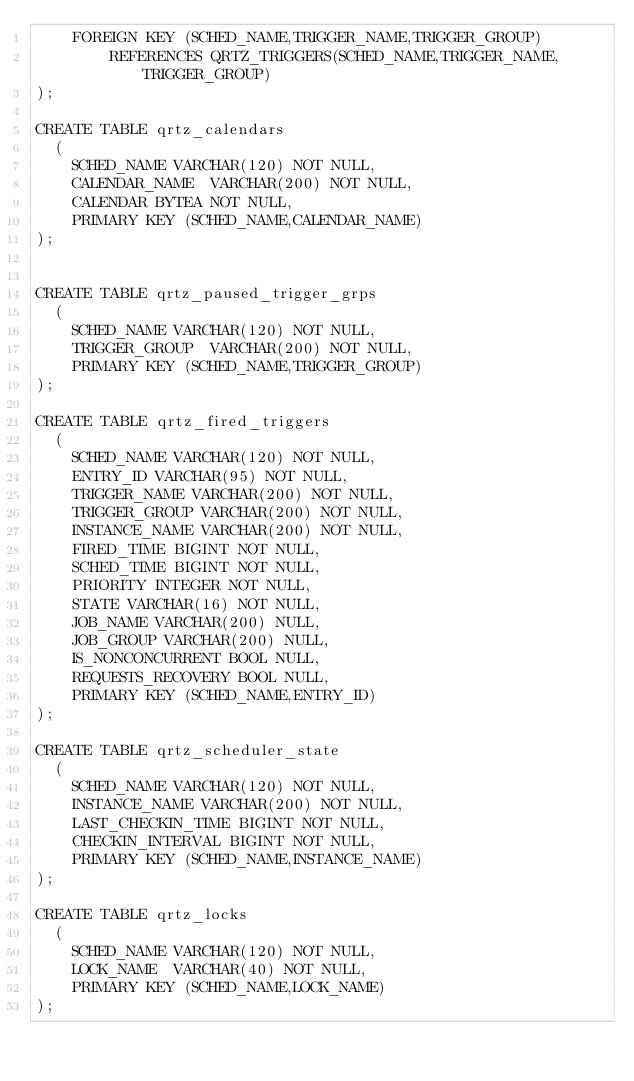Convert code to text. <code><loc_0><loc_0><loc_500><loc_500><_SQL_>    FOREIGN KEY (SCHED_NAME,TRIGGER_NAME,TRIGGER_GROUP) 
        REFERENCES QRTZ_TRIGGERS(SCHED_NAME,TRIGGER_NAME,TRIGGER_GROUP)
);

CREATE TABLE qrtz_calendars
  (
    SCHED_NAME VARCHAR(120) NOT NULL,
    CALENDAR_NAME  VARCHAR(200) NOT NULL, 
    CALENDAR BYTEA NOT NULL,
    PRIMARY KEY (SCHED_NAME,CALENDAR_NAME)
);


CREATE TABLE qrtz_paused_trigger_grps
  (
    SCHED_NAME VARCHAR(120) NOT NULL,
    TRIGGER_GROUP  VARCHAR(200) NOT NULL, 
    PRIMARY KEY (SCHED_NAME,TRIGGER_GROUP)
);

CREATE TABLE qrtz_fired_triggers 
  (
    SCHED_NAME VARCHAR(120) NOT NULL,
    ENTRY_ID VARCHAR(95) NOT NULL,
    TRIGGER_NAME VARCHAR(200) NOT NULL,
    TRIGGER_GROUP VARCHAR(200) NOT NULL,
    INSTANCE_NAME VARCHAR(200) NOT NULL,
    FIRED_TIME BIGINT NOT NULL,
    SCHED_TIME BIGINT NOT NULL,
    PRIORITY INTEGER NOT NULL,
    STATE VARCHAR(16) NOT NULL,
    JOB_NAME VARCHAR(200) NULL,
    JOB_GROUP VARCHAR(200) NULL,
    IS_NONCONCURRENT BOOL NULL,
    REQUESTS_RECOVERY BOOL NULL,
    PRIMARY KEY (SCHED_NAME,ENTRY_ID)
);

CREATE TABLE qrtz_scheduler_state 
  (
    SCHED_NAME VARCHAR(120) NOT NULL,
    INSTANCE_NAME VARCHAR(200) NOT NULL,
    LAST_CHECKIN_TIME BIGINT NOT NULL,
    CHECKIN_INTERVAL BIGINT NOT NULL,
    PRIMARY KEY (SCHED_NAME,INSTANCE_NAME)
);

CREATE TABLE qrtz_locks
  (
    SCHED_NAME VARCHAR(120) NOT NULL,
    LOCK_NAME  VARCHAR(40) NOT NULL, 
    PRIMARY KEY (SCHED_NAME,LOCK_NAME)
);
</code> 